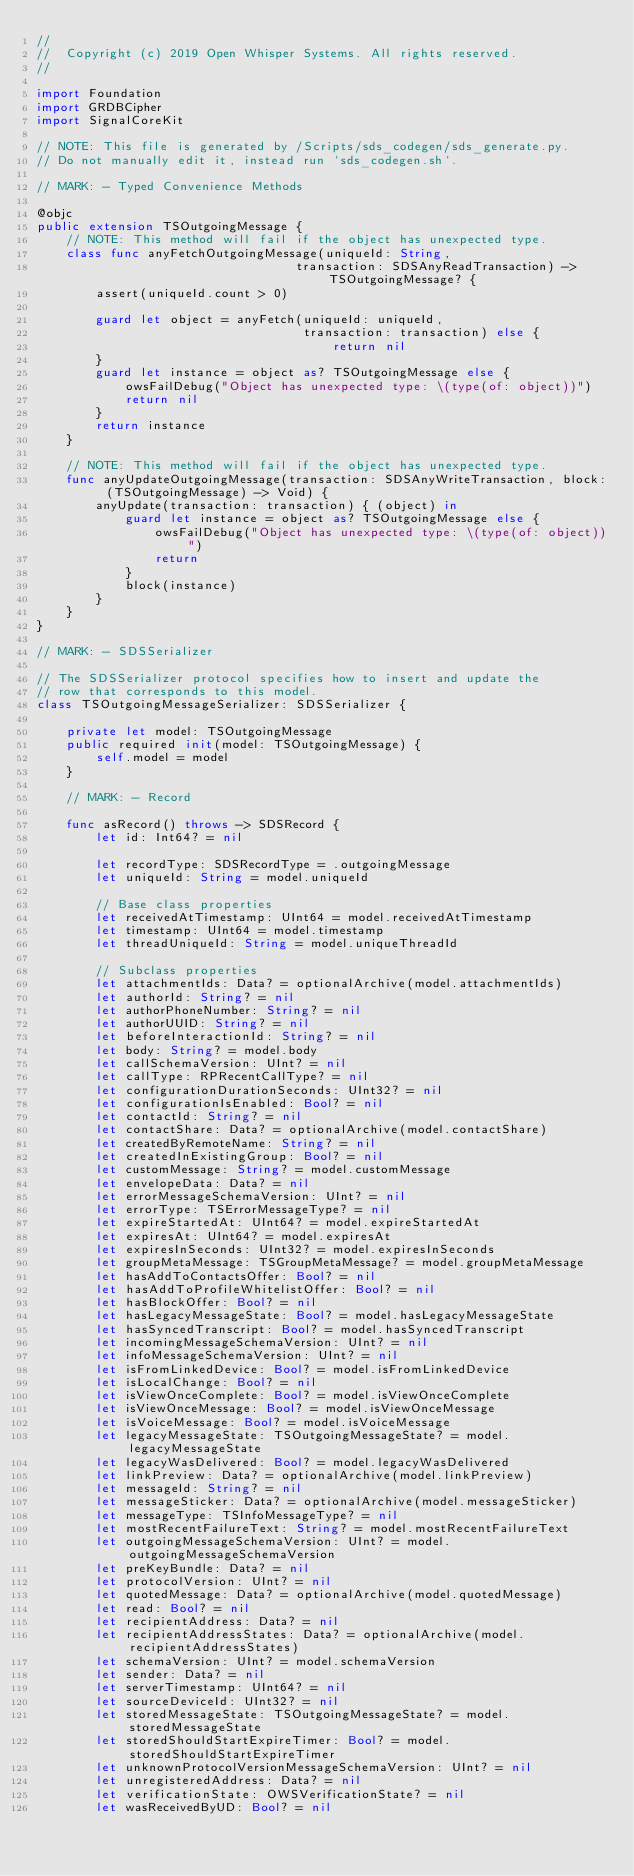<code> <loc_0><loc_0><loc_500><loc_500><_Swift_>//
//  Copyright (c) 2019 Open Whisper Systems. All rights reserved.
//

import Foundation
import GRDBCipher
import SignalCoreKit

// NOTE: This file is generated by /Scripts/sds_codegen/sds_generate.py.
// Do not manually edit it, instead run `sds_codegen.sh`.

// MARK: - Typed Convenience Methods

@objc
public extension TSOutgoingMessage {
    // NOTE: This method will fail if the object has unexpected type.
    class func anyFetchOutgoingMessage(uniqueId: String,
                                   transaction: SDSAnyReadTransaction) -> TSOutgoingMessage? {
        assert(uniqueId.count > 0)

        guard let object = anyFetch(uniqueId: uniqueId,
                                    transaction: transaction) else {
                                        return nil
        }
        guard let instance = object as? TSOutgoingMessage else {
            owsFailDebug("Object has unexpected type: \(type(of: object))")
            return nil
        }
        return instance
    }

    // NOTE: This method will fail if the object has unexpected type.
    func anyUpdateOutgoingMessage(transaction: SDSAnyWriteTransaction, block: (TSOutgoingMessage) -> Void) {
        anyUpdate(transaction: transaction) { (object) in
            guard let instance = object as? TSOutgoingMessage else {
                owsFailDebug("Object has unexpected type: \(type(of: object))")
                return
            }
            block(instance)
        }
    }
}

// MARK: - SDSSerializer

// The SDSSerializer protocol specifies how to insert and update the
// row that corresponds to this model.
class TSOutgoingMessageSerializer: SDSSerializer {

    private let model: TSOutgoingMessage
    public required init(model: TSOutgoingMessage) {
        self.model = model
    }

    // MARK: - Record

    func asRecord() throws -> SDSRecord {
        let id: Int64? = nil

        let recordType: SDSRecordType = .outgoingMessage
        let uniqueId: String = model.uniqueId

        // Base class properties
        let receivedAtTimestamp: UInt64 = model.receivedAtTimestamp
        let timestamp: UInt64 = model.timestamp
        let threadUniqueId: String = model.uniqueThreadId

        // Subclass properties
        let attachmentIds: Data? = optionalArchive(model.attachmentIds)
        let authorId: String? = nil
        let authorPhoneNumber: String? = nil
        let authorUUID: String? = nil
        let beforeInteractionId: String? = nil
        let body: String? = model.body
        let callSchemaVersion: UInt? = nil
        let callType: RPRecentCallType? = nil
        let configurationDurationSeconds: UInt32? = nil
        let configurationIsEnabled: Bool? = nil
        let contactId: String? = nil
        let contactShare: Data? = optionalArchive(model.contactShare)
        let createdByRemoteName: String? = nil
        let createdInExistingGroup: Bool? = nil
        let customMessage: String? = model.customMessage
        let envelopeData: Data? = nil
        let errorMessageSchemaVersion: UInt? = nil
        let errorType: TSErrorMessageType? = nil
        let expireStartedAt: UInt64? = model.expireStartedAt
        let expiresAt: UInt64? = model.expiresAt
        let expiresInSeconds: UInt32? = model.expiresInSeconds
        let groupMetaMessage: TSGroupMetaMessage? = model.groupMetaMessage
        let hasAddToContactsOffer: Bool? = nil
        let hasAddToProfileWhitelistOffer: Bool? = nil
        let hasBlockOffer: Bool? = nil
        let hasLegacyMessageState: Bool? = model.hasLegacyMessageState
        let hasSyncedTranscript: Bool? = model.hasSyncedTranscript
        let incomingMessageSchemaVersion: UInt? = nil
        let infoMessageSchemaVersion: UInt? = nil
        let isFromLinkedDevice: Bool? = model.isFromLinkedDevice
        let isLocalChange: Bool? = nil
        let isViewOnceComplete: Bool? = model.isViewOnceComplete
        let isViewOnceMessage: Bool? = model.isViewOnceMessage
        let isVoiceMessage: Bool? = model.isVoiceMessage
        let legacyMessageState: TSOutgoingMessageState? = model.legacyMessageState
        let legacyWasDelivered: Bool? = model.legacyWasDelivered
        let linkPreview: Data? = optionalArchive(model.linkPreview)
        let messageId: String? = nil
        let messageSticker: Data? = optionalArchive(model.messageSticker)
        let messageType: TSInfoMessageType? = nil
        let mostRecentFailureText: String? = model.mostRecentFailureText
        let outgoingMessageSchemaVersion: UInt? = model.outgoingMessageSchemaVersion
        let preKeyBundle: Data? = nil
        let protocolVersion: UInt? = nil
        let quotedMessage: Data? = optionalArchive(model.quotedMessage)
        let read: Bool? = nil
        let recipientAddress: Data? = nil
        let recipientAddressStates: Data? = optionalArchive(model.recipientAddressStates)
        let schemaVersion: UInt? = model.schemaVersion
        let sender: Data? = nil
        let serverTimestamp: UInt64? = nil
        let sourceDeviceId: UInt32? = nil
        let storedMessageState: TSOutgoingMessageState? = model.storedMessageState
        let storedShouldStartExpireTimer: Bool? = model.storedShouldStartExpireTimer
        let unknownProtocolVersionMessageSchemaVersion: UInt? = nil
        let unregisteredAddress: Data? = nil
        let verificationState: OWSVerificationState? = nil
        let wasReceivedByUD: Bool? = nil
</code> 